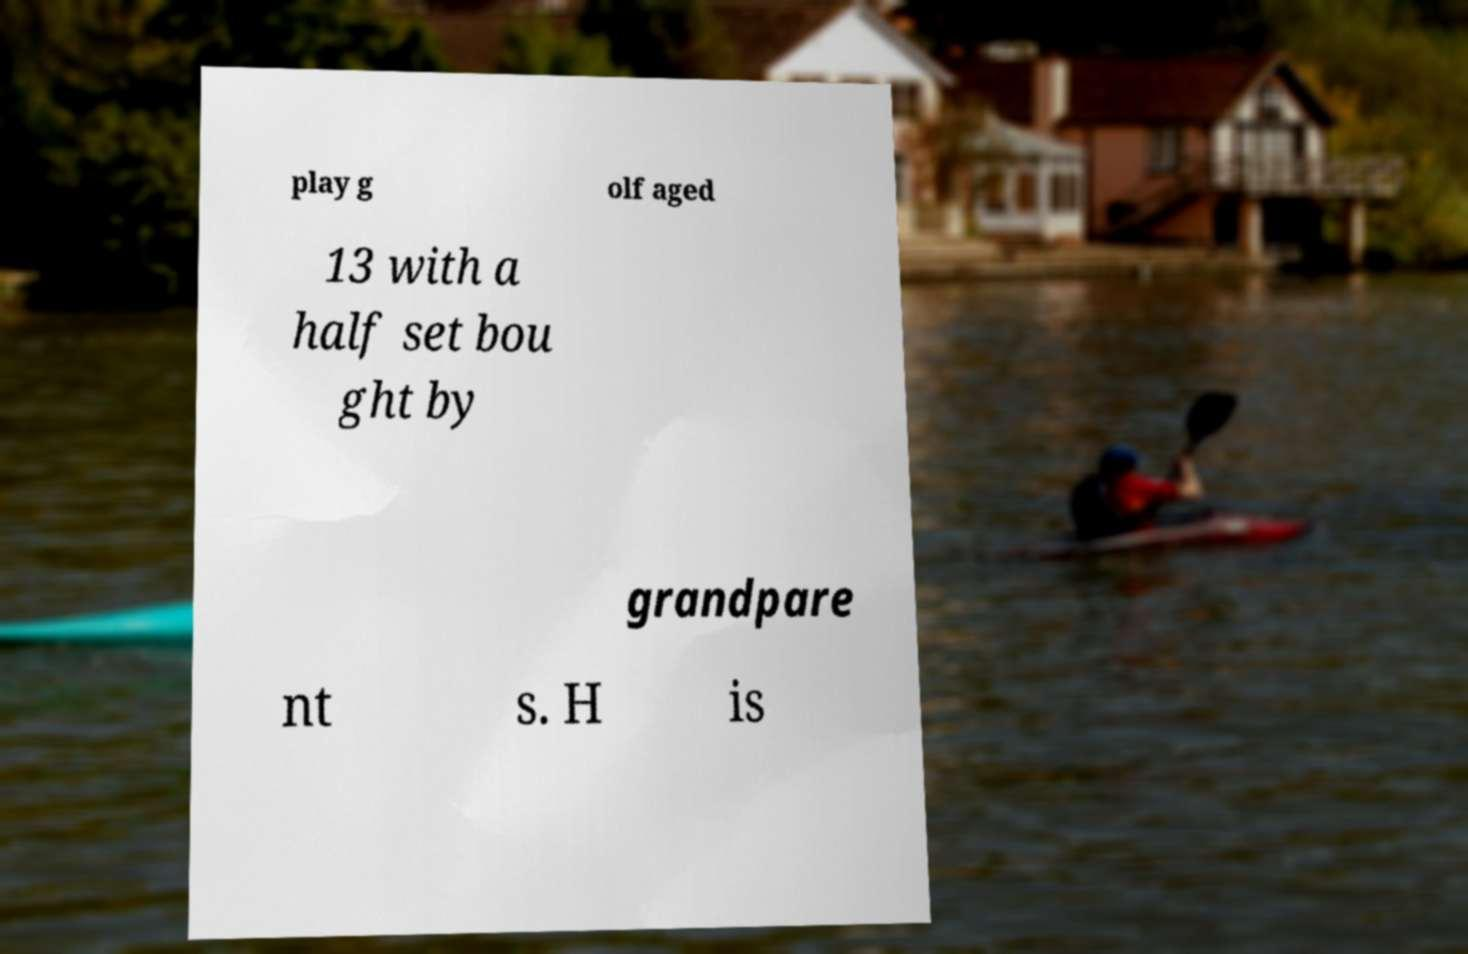Can you read and provide the text displayed in the image?This photo seems to have some interesting text. Can you extract and type it out for me? play g olf aged 13 with a half set bou ght by grandpare nt s. H is 